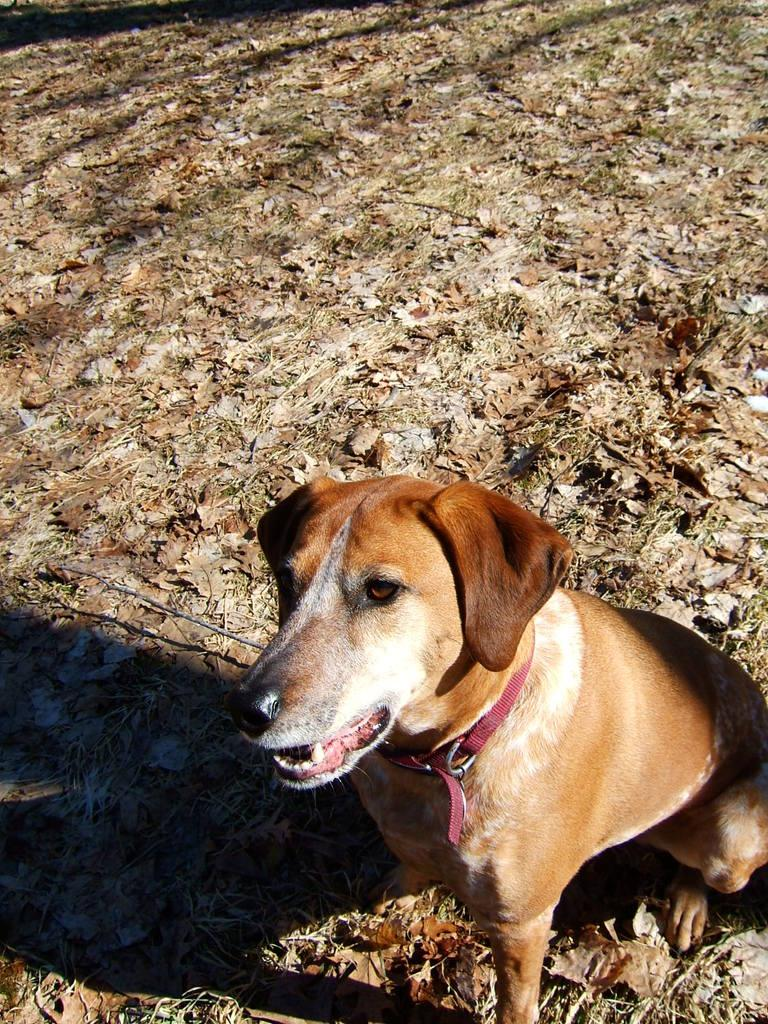What type of animal is in the image? There is a brown dog in the image. What is the dog doing in the image? The dog has its mouth opened and is sitting on the ground. What can be seen on the ground in the image? There are dry leaves and grass on the ground. Can you tell me how many goldfish are swimming in the image? There are no goldfish present in the image; it features a brown dog sitting on the ground. What type of account is the dog managing in the image? There is no account management depicted in the image; it shows a brown dog sitting on the ground with its mouth opened. 